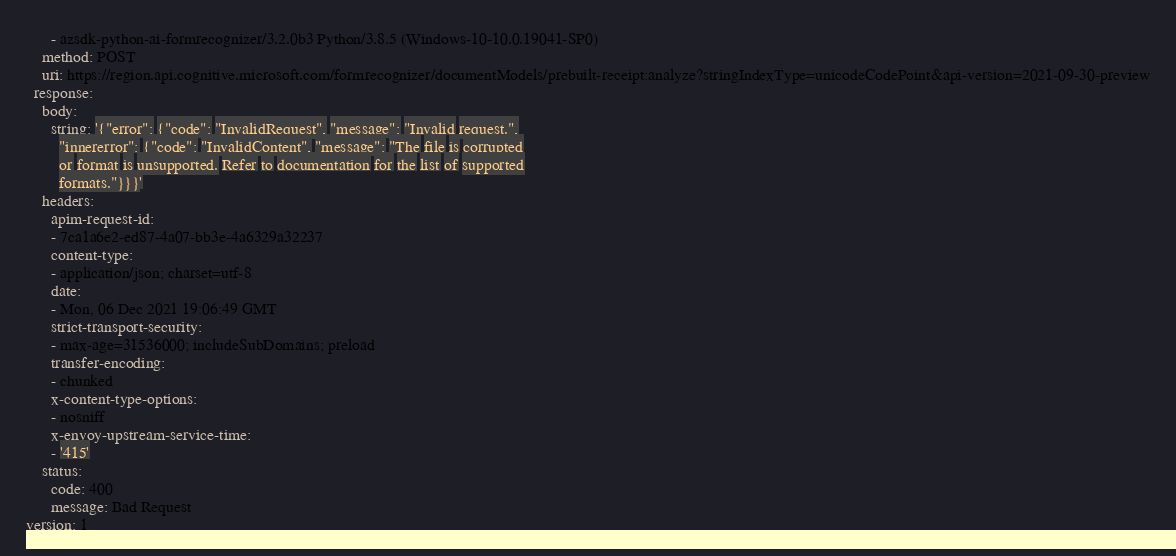Convert code to text. <code><loc_0><loc_0><loc_500><loc_500><_YAML_>      - azsdk-python-ai-formrecognizer/3.2.0b3 Python/3.8.5 (Windows-10-10.0.19041-SP0)
    method: POST
    uri: https://region.api.cognitive.microsoft.com/formrecognizer/documentModels/prebuilt-receipt:analyze?stringIndexType=unicodeCodePoint&api-version=2021-09-30-preview
  response:
    body:
      string: '{"error": {"code": "InvalidRequest", "message": "Invalid request.",
        "innererror": {"code": "InvalidContent", "message": "The file is corrupted
        or format is unsupported. Refer to documentation for the list of supported
        formats."}}}'
    headers:
      apim-request-id:
      - 7ca1a6e2-ed87-4a07-bb3e-4a6329a32237
      content-type:
      - application/json; charset=utf-8
      date:
      - Mon, 06 Dec 2021 19:06:49 GMT
      strict-transport-security:
      - max-age=31536000; includeSubDomains; preload
      transfer-encoding:
      - chunked
      x-content-type-options:
      - nosniff
      x-envoy-upstream-service-time:
      - '415'
    status:
      code: 400
      message: Bad Request
version: 1
</code> 